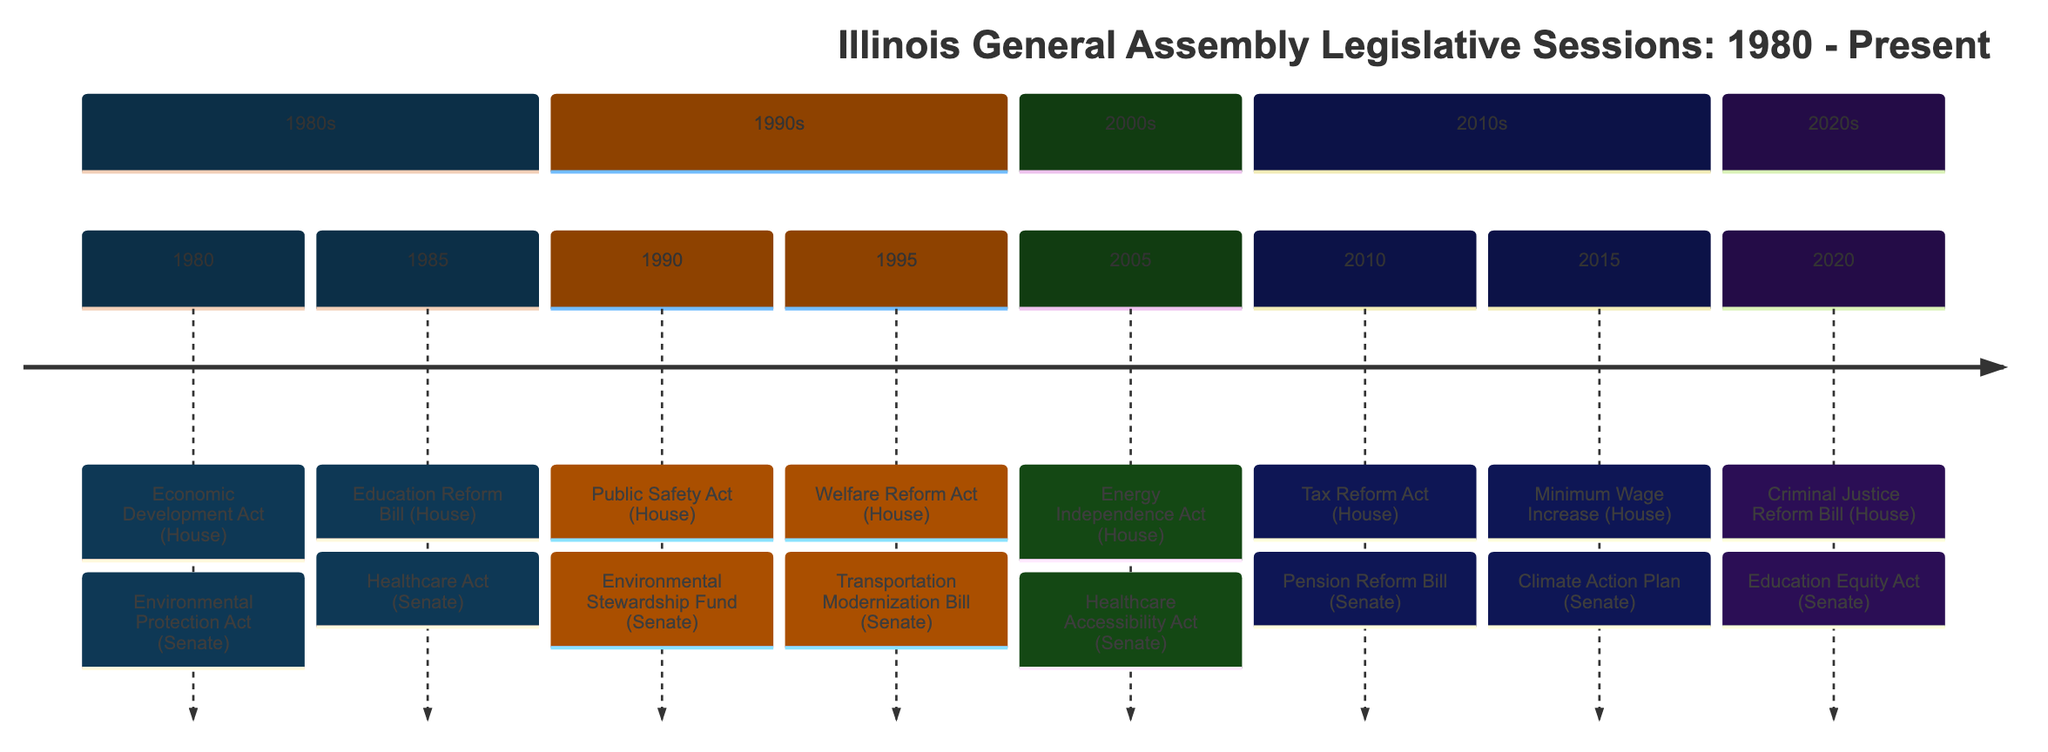What significant act was passed by the House in 1980? In the timeline, looking at the year 1980, the House passed the "Economic Development Act," which is the first event listed for that year.
Answer: Economic Development Act Which act focused on healthcare in 1985? The Senate introduced the "Healthcare Act" in 1985, which is the event corresponding to the Senate's action for that year.
Answer: Healthcare Act How many major legislative actions are noted in the year 1995? In 1995, there are two events noted in the timeline: one from the House (Welfare Reform Act) and one from the Senate (Transportation Modernization Bill), making a total of two actions.
Answer: 2 What was the focus of the Senate's Environmental Protection Act in 1980? The event description for the Senate's Environmental Protection Act in 1980 states that it introduced stricter regulations on industrial pollution, indicating its focus on environmental issues.
Answer: Stricter regulations Which House bill enacted changes to criminal justice in 2020? Looking at 2020, the House passed the "Criminal Justice Reform Bill," and that's the specific bill related to criminal justice enacted that year.
Answer: Criminal Justice Reform Bill What color represents the House actions in the timeline? The color coding provided indicates that House actions are represented by the color "#1f77b4," which is the specified primary color for House events in the timeline.
Answer: #1f77b4 What legislative area does the "Energy Independence Act" address? The "Energy Independence Act," passed by the House in 2005, promotes renewable energy sources and focuses on reducing reliance on fossil fuels, indicating its area of focus.
Answer: Renewable energy Which year saw the introduction of the Education Equity Act by the Senate? The Education Equity Act is noted as having been introduced by the Senate in the year 2020, making that the year in question regarding its introduction.
Answer: 2020 Which act passed in 2015 aimed to increase pay for workers? The "Minimum Wage Increase" passed in the House in 2015 directly indicates it aimed to raise the state minimum wage, focused on improving pay for low-income workers.
Answer: Minimum Wage Increase 